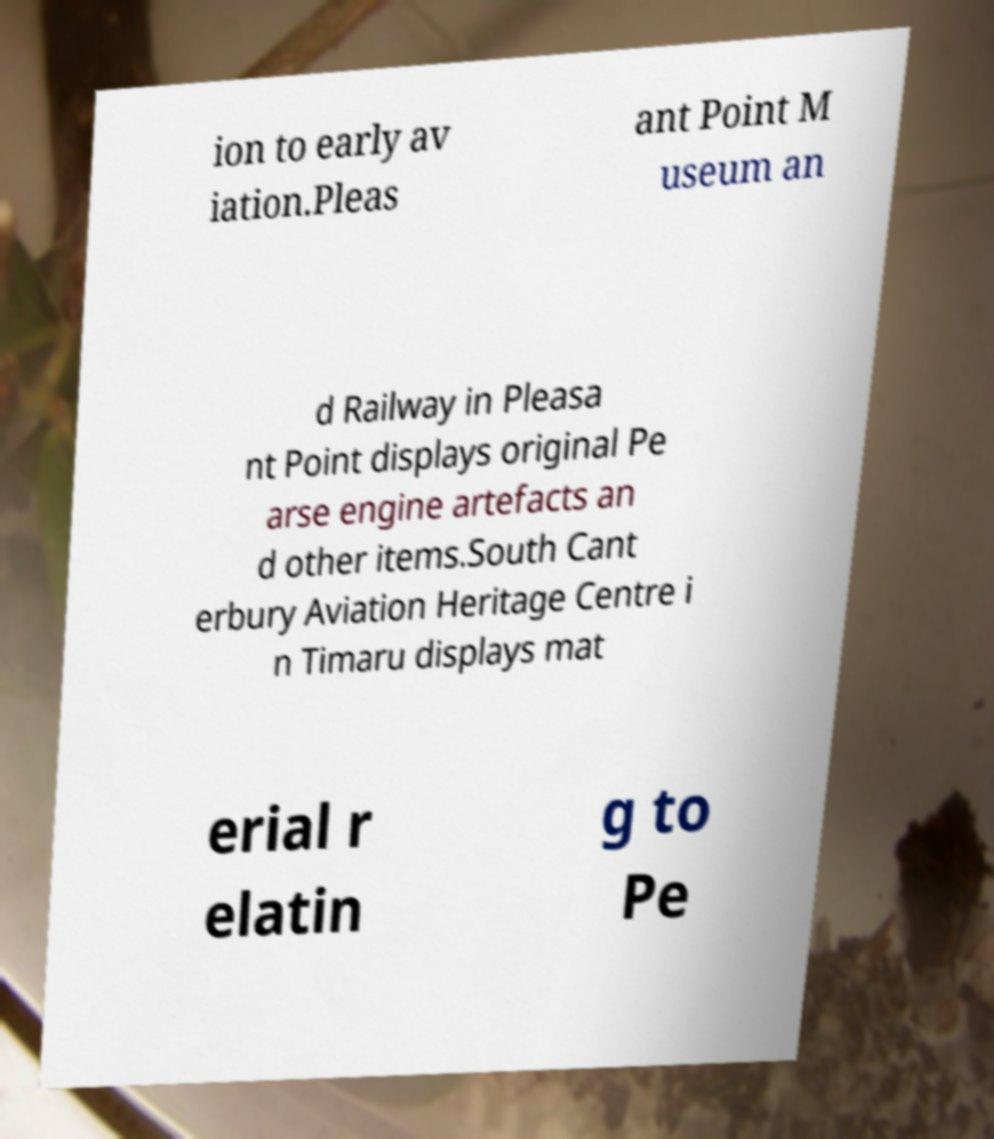Can you read and provide the text displayed in the image?This photo seems to have some interesting text. Can you extract and type it out for me? ion to early av iation.Pleas ant Point M useum an d Railway in Pleasa nt Point displays original Pe arse engine artefacts an d other items.South Cant erbury Aviation Heritage Centre i n Timaru displays mat erial r elatin g to Pe 